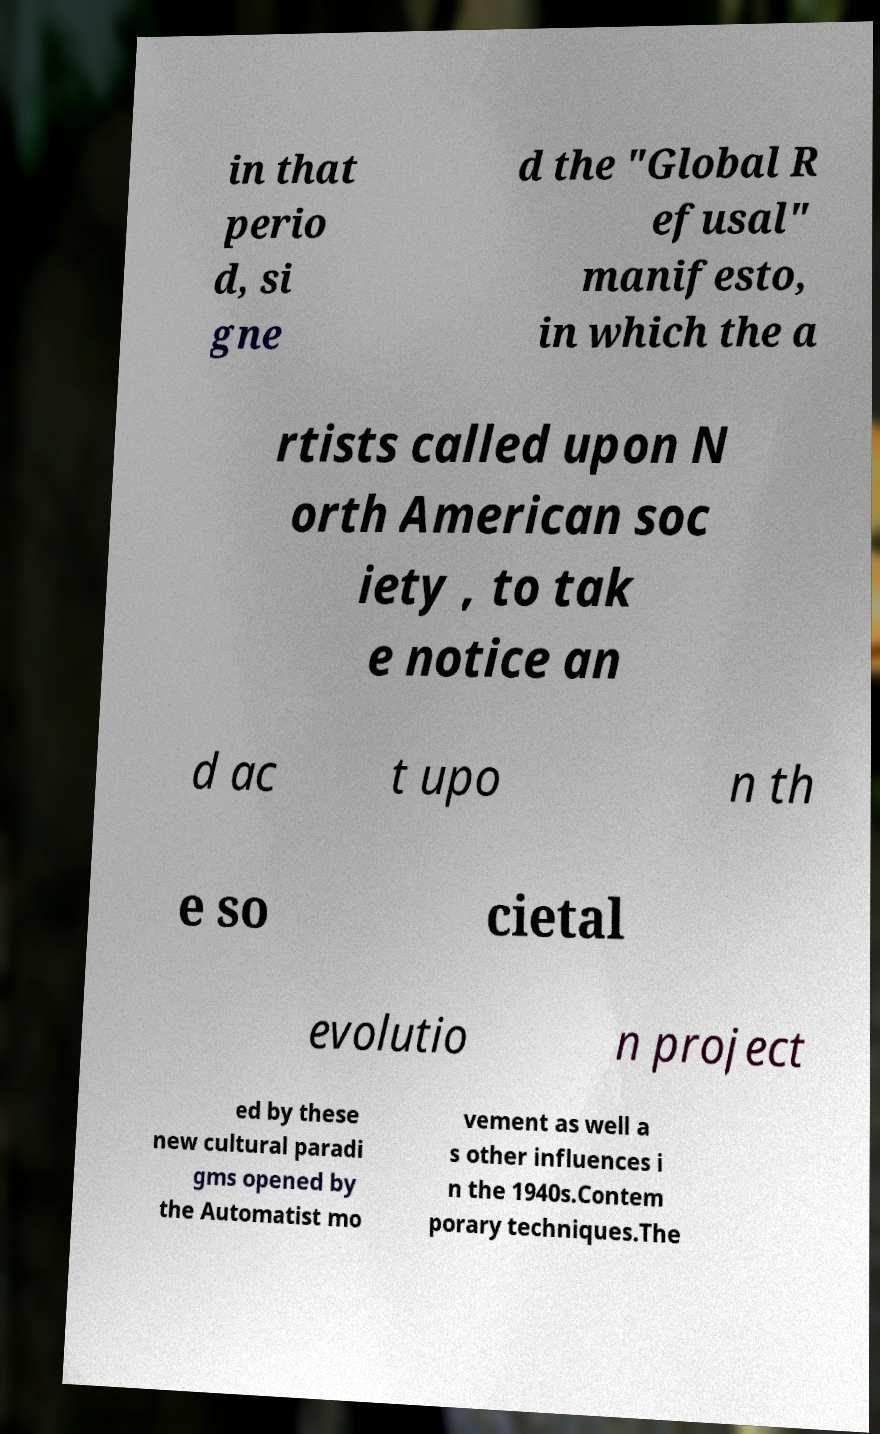What messages or text are displayed in this image? I need them in a readable, typed format. in that perio d, si gne d the "Global R efusal" manifesto, in which the a rtists called upon N orth American soc iety , to tak e notice an d ac t upo n th e so cietal evolutio n project ed by these new cultural paradi gms opened by the Automatist mo vement as well a s other influences i n the 1940s.Contem porary techniques.The 